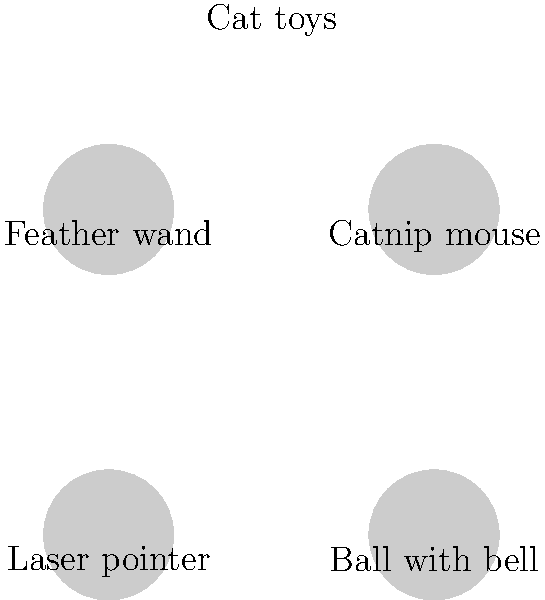In a machine learning model for image recognition of cat toys, which feature would be most useful for distinguishing a laser pointer from other toys? To distinguish a laser pointer from other cat toys using image recognition, we need to consider the unique features of each toy:

1. Feather wand: Typically long and thin with feathers at one end.
2. Catnip mouse: Usually small, furry, and mouse-shaped.
3. Laser pointer: Small, cylindrical shape with a distinct lens at one end.
4. Ball with bell: Spherical shape, often with a textured surface.

The laser pointer's most distinguishing feature is its cylindrical shape and the presence of a lens. This is unique compared to the other toys:

1. It lacks the feathery texture of the wand.
2. It's not furry or mouse-shaped like the catnip toy.
3. It's not spherical like the ball.

In image recognition, the model would likely focus on:

1. Shape detection: Looking for a cylindrical object.
2. Lens detection: Identifying the reflective lens surface.
3. Size analysis: Laser pointers are typically smaller than most other cat toys.
4. Texture analysis: Smooth surface compared to furry or feathery textures.

The most crucial feature would be the presence of a lens, as this is unique to the laser pointer among these cat toys.
Answer: Presence of a lens 